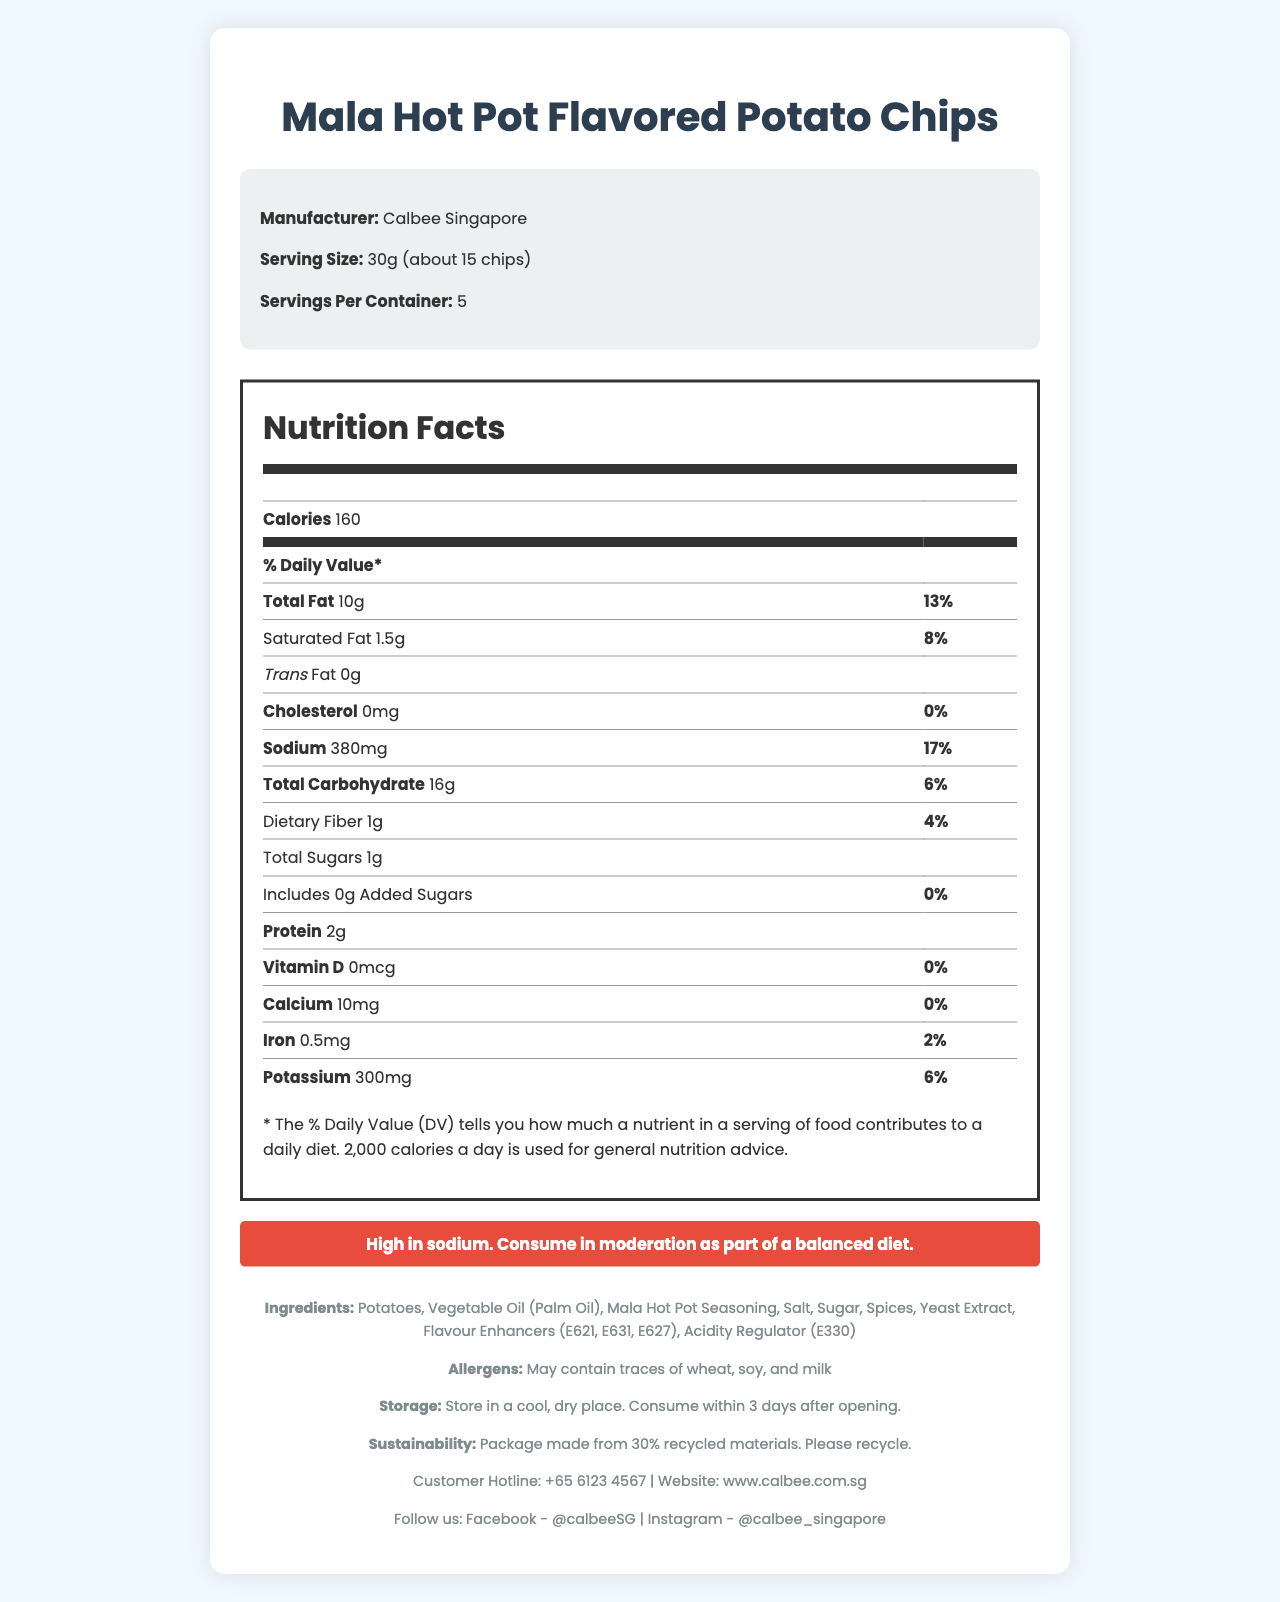what is the serving size? The serving size is clearly mentioned in the product info section as 30g which is about 15 chips.
Answer: 30g (about 15 chips) who is the manufacturer of the Mala Hot Pot Flavored Potato Chips? The manufacturer is listed in the product info section as Calbee Singapore.
Answer: Calbee Singapore how many servings are there in one container? The number of servings per container is listed in the product info as "Servings Per Container: 5."
Answer: 5 what is the total sodium content per serving? The sodium content is identified in the nutrition label section under "Sodium", showing 380mg.
Answer: 380mg what is the percentage Daily Value of Sodium? The percentage Daily Value of Sodium is listed in the nutrition label section as 17%.
Answer: 17% does the product contain any trans fat? The nutrition label section specifies "Trans Fat 0g," which means there is no trans fat in the product.
Answer: No what is the warning given about sodium consumption? The health advisory section has a clear warning regarding the high sodium content and advises consumption in moderation.
Answer: High in sodium. Consume in moderation as part of a balanced diet. what allergens may be present in the snack? A. Peanuts B. Soy C. Shellfish D. Eggs The allergens section specifies "May contain traces of wheat, soy, and milk," making soy the correct answer.
Answer: B. Soy what are the first two ingredients listed? A. Salt and Sugar B. Potato and Salt C. Potatoes and Vegetable Oil The ingredients list shows "Potatoes" and "Vegetable Oil" (Palm Oil) as the first two ingredients.
Answer: C. Potatoes and Vegetable Oil is this snack a good source of dietary fiber? The amount of dietary fiber is only 1g per serving, which constitutes just 4% of the Daily Value, indicating it is not a particularly good source of dietary fiber.
Answer: No what should you do with the package after consumption? The sustainability info section suggests that the package is made from 30% recycled materials and encourages you to recycle.
Answer: Please recycle what is the customer hotline number? The customer hotline is provided in the footer section as +65 6123 4567.
Answer: +65 6123 4567 what vitamins or minerals does this snack provide and in what amounts? The nutrition label lists the amounts of Vitamin D, Calcium, Iron, and Potassium.
Answer: Vitamin D (0mcg), Calcium (10mg), Iron (0.5mg), Potassium (300mg) describe the entire document or the main idea of the document. The document is a comprehensive view of the Mala Hot Pot Flavored Potato Chips, giving a complete picture of the product from nutritional content and health warnings to contact and sustainability details.
Answer: The document provides detailed information about the Mala Hot Pot Flavored Potato Chips, including its nutritional facts, ingredients, allergens, health advisory, and storage instructions. It highlights the high sodium content and advises moderate consumption. References to sustainability and recycling, along with customer service details, are included. does this snack contain any added sugars? True or False The nutrition label states "Includes 0g Added Sugars," meaning there are no added sugars in this snack.
Answer: False how many calories are in one serving of the chips? The total calorie content per serving is listed in the nutrition label as 160 calories.
Answer: 160 calories can this snack be stored at room temperature? The storage instructions specify that the snack should be stored in a cool, dry place, which typically corresponds to room temperature storage conditions.
Answer: Yes what is the amount of total fat per serving and its % daily value? The nutrition label shows "Total Fat 10g" with a daily value of 13%, clearly indicating both the amount and the percentage.
Answer: 10g, 13% how long can the chips be consumed after opening? The storage instructions mention that the product should be consumed within 3 days after opening.
Answer: 3 days how often should you consume this snack? While the document advises consuming the snack in moderation due to its high sodium content, it does not specify a frequency of consumption.
Answer: Not enough information 